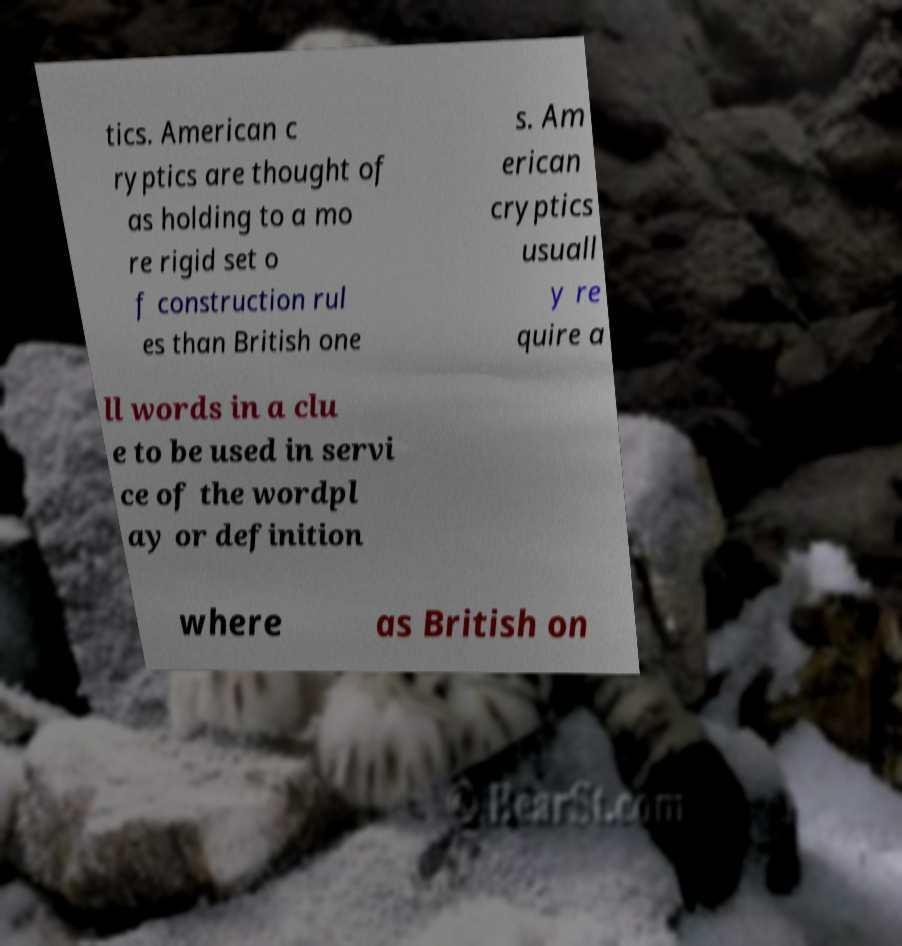Could you extract and type out the text from this image? tics. American c ryptics are thought of as holding to a mo re rigid set o f construction rul es than British one s. Am erican cryptics usuall y re quire a ll words in a clu e to be used in servi ce of the wordpl ay or definition where as British on 